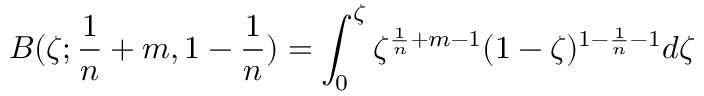Convert formula to latex. <formula><loc_0><loc_0><loc_500><loc_500>B ( \zeta ; \frac { 1 } { n } + m , 1 - \frac { 1 } { n } ) = \int _ { 0 } ^ { \zeta } \zeta ^ { \frac { 1 } { n } + m - 1 } ( 1 - \zeta ) ^ { 1 - \frac { 1 } { n } - 1 } d \zeta</formula> 